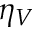<formula> <loc_0><loc_0><loc_500><loc_500>\eta _ { V }</formula> 